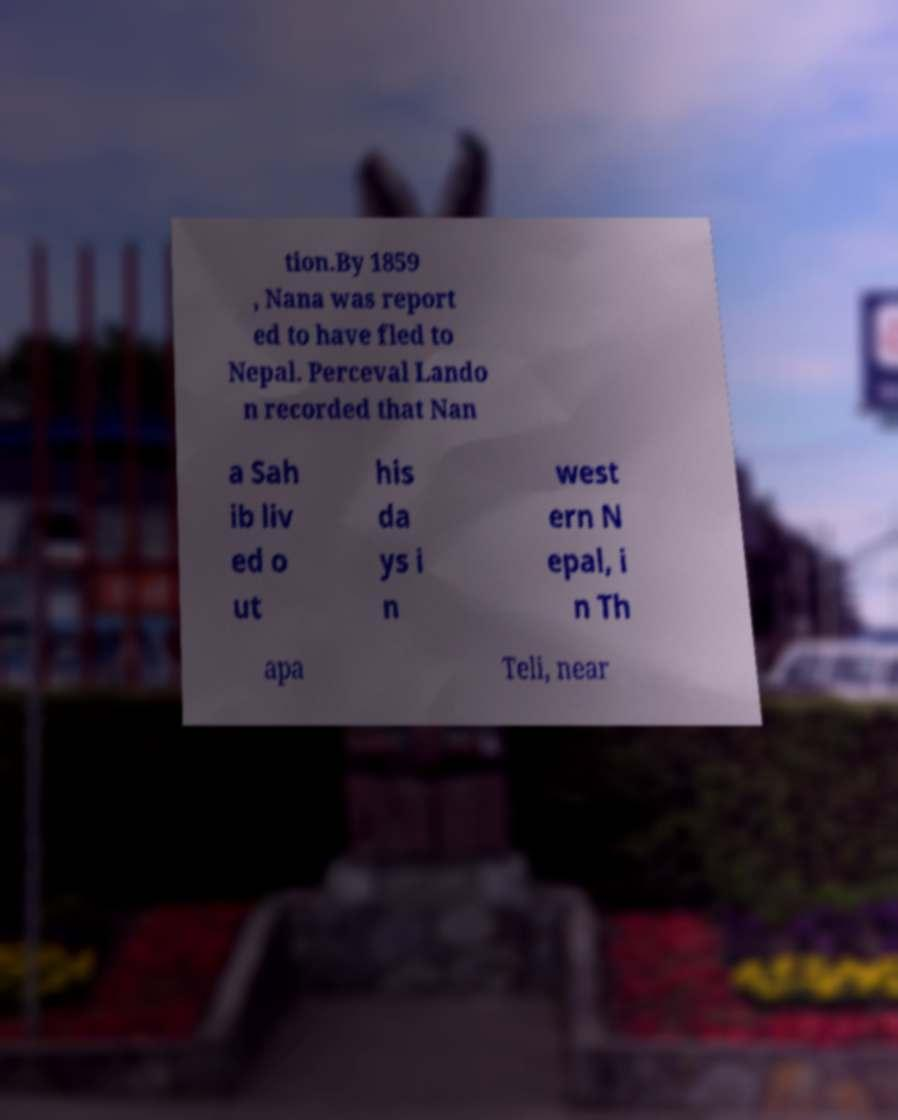Can you read and provide the text displayed in the image?This photo seems to have some interesting text. Can you extract and type it out for me? tion.By 1859 , Nana was report ed to have fled to Nepal. Perceval Lando n recorded that Nan a Sah ib liv ed o ut his da ys i n west ern N epal, i n Th apa Teli, near 